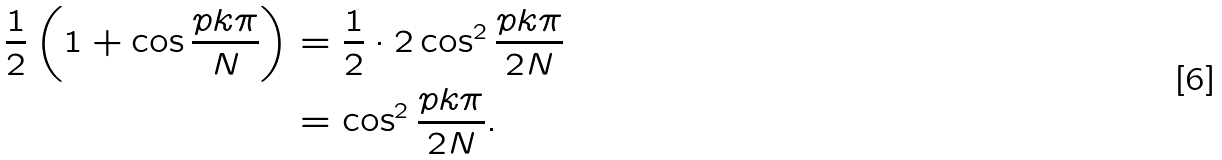Convert formula to latex. <formula><loc_0><loc_0><loc_500><loc_500>\frac { 1 } { 2 } \left ( 1 + \cos \frac { p k \pi } { N } \right ) & = \frac { 1 } { 2 } \cdot 2 \cos ^ { 2 } \frac { p k \pi } { 2 N } \\ & = \cos ^ { 2 } \frac { p k \pi } { 2 N } .</formula> 